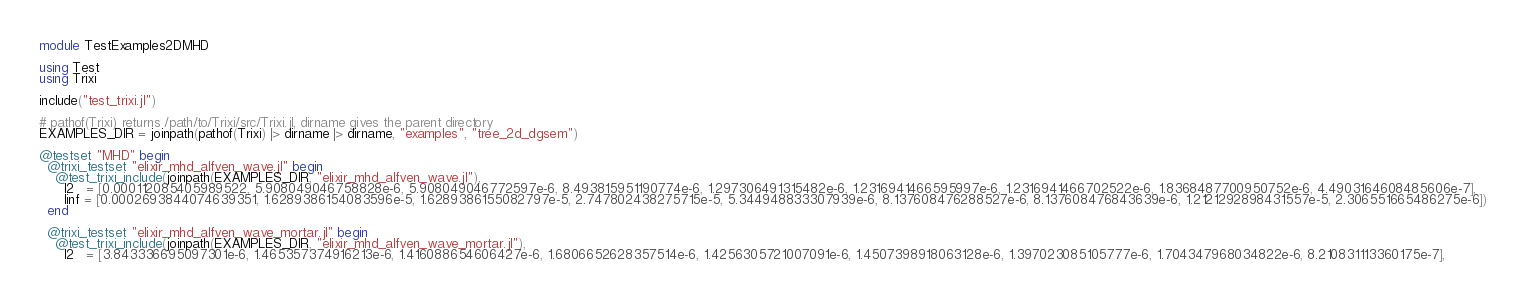Convert code to text. <code><loc_0><loc_0><loc_500><loc_500><_Julia_>module TestExamples2DMHD

using Test
using Trixi

include("test_trixi.jl")

# pathof(Trixi) returns /path/to/Trixi/src/Trixi.jl, dirname gives the parent directory
EXAMPLES_DIR = joinpath(pathof(Trixi) |> dirname |> dirname, "examples", "tree_2d_dgsem")

@testset "MHD" begin
  @trixi_testset "elixir_mhd_alfven_wave.jl" begin
    @test_trixi_include(joinpath(EXAMPLES_DIR, "elixir_mhd_alfven_wave.jl"),
      l2   = [0.000112085405989522, 5.908049046758828e-6, 5.908049046772597e-6, 8.493815951190774e-6, 1.297306491315482e-6, 1.2316941466595997e-6, 1.2316941466702522e-6, 1.8368487700950752e-6, 4.4903164608485606e-7],
      linf = [0.0002693844074639351, 1.6289386154083596e-5, 1.6289386155082797e-5, 2.747802438275715e-5, 5.344948833307939e-6, 8.137608476288527e-6, 8.137608476843639e-6, 1.2121292898431557e-5, 2.306551665486275e-6])
  end

  @trixi_testset "elixir_mhd_alfven_wave_mortar.jl" begin
    @test_trixi_include(joinpath(EXAMPLES_DIR, "elixir_mhd_alfven_wave_mortar.jl"),
      l2   = [3.843336695097301e-6, 1.465357374916213e-6, 1.416088654606427e-6, 1.6806652628357514e-6, 1.4256305721007091e-6, 1.4507398918063128e-6, 1.397023085105777e-6, 1.704347968034822e-6, 8.210831113360175e-7],</code> 